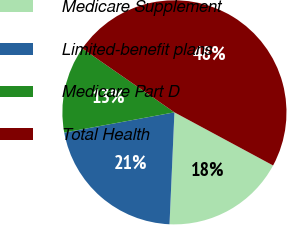<chart> <loc_0><loc_0><loc_500><loc_500><pie_chart><fcel>Medicare Supplement<fcel>Limited-benefit plans<fcel>Medicare Part D<fcel>Total Health<nl><fcel>17.84%<fcel>21.41%<fcel>12.54%<fcel>48.22%<nl></chart> 